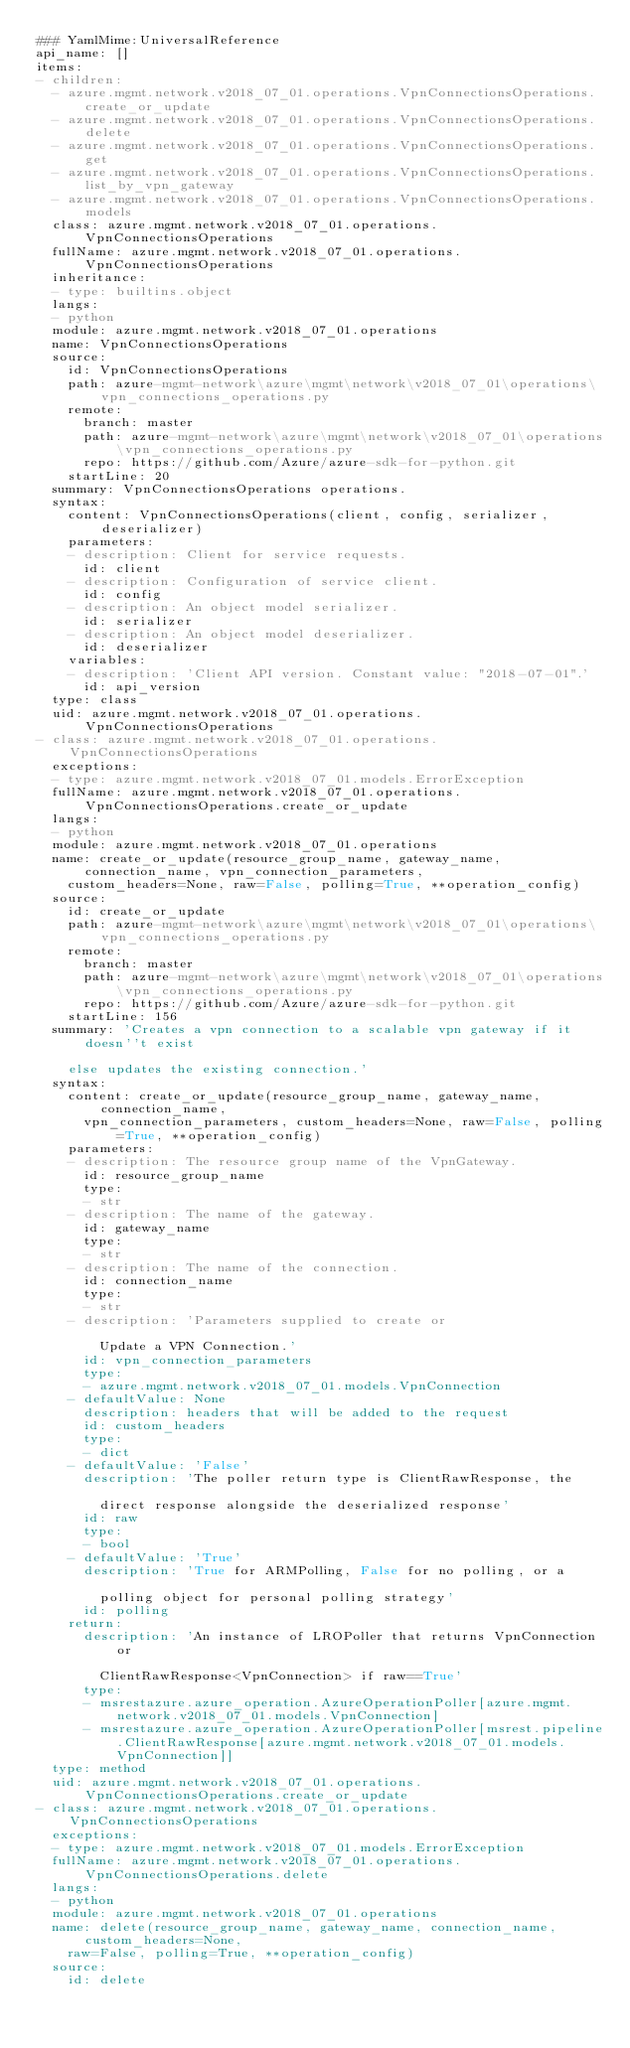<code> <loc_0><loc_0><loc_500><loc_500><_YAML_>### YamlMime:UniversalReference
api_name: []
items:
- children:
  - azure.mgmt.network.v2018_07_01.operations.VpnConnectionsOperations.create_or_update
  - azure.mgmt.network.v2018_07_01.operations.VpnConnectionsOperations.delete
  - azure.mgmt.network.v2018_07_01.operations.VpnConnectionsOperations.get
  - azure.mgmt.network.v2018_07_01.operations.VpnConnectionsOperations.list_by_vpn_gateway
  - azure.mgmt.network.v2018_07_01.operations.VpnConnectionsOperations.models
  class: azure.mgmt.network.v2018_07_01.operations.VpnConnectionsOperations
  fullName: azure.mgmt.network.v2018_07_01.operations.VpnConnectionsOperations
  inheritance:
  - type: builtins.object
  langs:
  - python
  module: azure.mgmt.network.v2018_07_01.operations
  name: VpnConnectionsOperations
  source:
    id: VpnConnectionsOperations
    path: azure-mgmt-network\azure\mgmt\network\v2018_07_01\operations\vpn_connections_operations.py
    remote:
      branch: master
      path: azure-mgmt-network\azure\mgmt\network\v2018_07_01\operations\vpn_connections_operations.py
      repo: https://github.com/Azure/azure-sdk-for-python.git
    startLine: 20
  summary: VpnConnectionsOperations operations.
  syntax:
    content: VpnConnectionsOperations(client, config, serializer, deserializer)
    parameters:
    - description: Client for service requests.
      id: client
    - description: Configuration of service client.
      id: config
    - description: An object model serializer.
      id: serializer
    - description: An object model deserializer.
      id: deserializer
    variables:
    - description: 'Client API version. Constant value: "2018-07-01".'
      id: api_version
  type: class
  uid: azure.mgmt.network.v2018_07_01.operations.VpnConnectionsOperations
- class: azure.mgmt.network.v2018_07_01.operations.VpnConnectionsOperations
  exceptions:
  - type: azure.mgmt.network.v2018_07_01.models.ErrorException
  fullName: azure.mgmt.network.v2018_07_01.operations.VpnConnectionsOperations.create_or_update
  langs:
  - python
  module: azure.mgmt.network.v2018_07_01.operations
  name: create_or_update(resource_group_name, gateway_name, connection_name, vpn_connection_parameters,
    custom_headers=None, raw=False, polling=True, **operation_config)
  source:
    id: create_or_update
    path: azure-mgmt-network\azure\mgmt\network\v2018_07_01\operations\vpn_connections_operations.py
    remote:
      branch: master
      path: azure-mgmt-network\azure\mgmt\network\v2018_07_01\operations\vpn_connections_operations.py
      repo: https://github.com/Azure/azure-sdk-for-python.git
    startLine: 156
  summary: 'Creates a vpn connection to a scalable vpn gateway if it doesn''t exist

    else updates the existing connection.'
  syntax:
    content: create_or_update(resource_group_name, gateway_name, connection_name,
      vpn_connection_parameters, custom_headers=None, raw=False, polling=True, **operation_config)
    parameters:
    - description: The resource group name of the VpnGateway.
      id: resource_group_name
      type:
      - str
    - description: The name of the gateway.
      id: gateway_name
      type:
      - str
    - description: The name of the connection.
      id: connection_name
      type:
      - str
    - description: 'Parameters supplied to create or

        Update a VPN Connection.'
      id: vpn_connection_parameters
      type:
      - azure.mgmt.network.v2018_07_01.models.VpnConnection
    - defaultValue: None
      description: headers that will be added to the request
      id: custom_headers
      type:
      - dict
    - defaultValue: 'False'
      description: 'The poller return type is ClientRawResponse, the

        direct response alongside the deserialized response'
      id: raw
      type:
      - bool
    - defaultValue: 'True'
      description: 'True for ARMPolling, False for no polling, or a

        polling object for personal polling strategy'
      id: polling
    return:
      description: 'An instance of LROPoller that returns VpnConnection or

        ClientRawResponse<VpnConnection> if raw==True'
      type:
      - msrestazure.azure_operation.AzureOperationPoller[azure.mgmt.network.v2018_07_01.models.VpnConnection]
      - msrestazure.azure_operation.AzureOperationPoller[msrest.pipeline.ClientRawResponse[azure.mgmt.network.v2018_07_01.models.VpnConnection]]
  type: method
  uid: azure.mgmt.network.v2018_07_01.operations.VpnConnectionsOperations.create_or_update
- class: azure.mgmt.network.v2018_07_01.operations.VpnConnectionsOperations
  exceptions:
  - type: azure.mgmt.network.v2018_07_01.models.ErrorException
  fullName: azure.mgmt.network.v2018_07_01.operations.VpnConnectionsOperations.delete
  langs:
  - python
  module: azure.mgmt.network.v2018_07_01.operations
  name: delete(resource_group_name, gateway_name, connection_name, custom_headers=None,
    raw=False, polling=True, **operation_config)
  source:
    id: delete</code> 